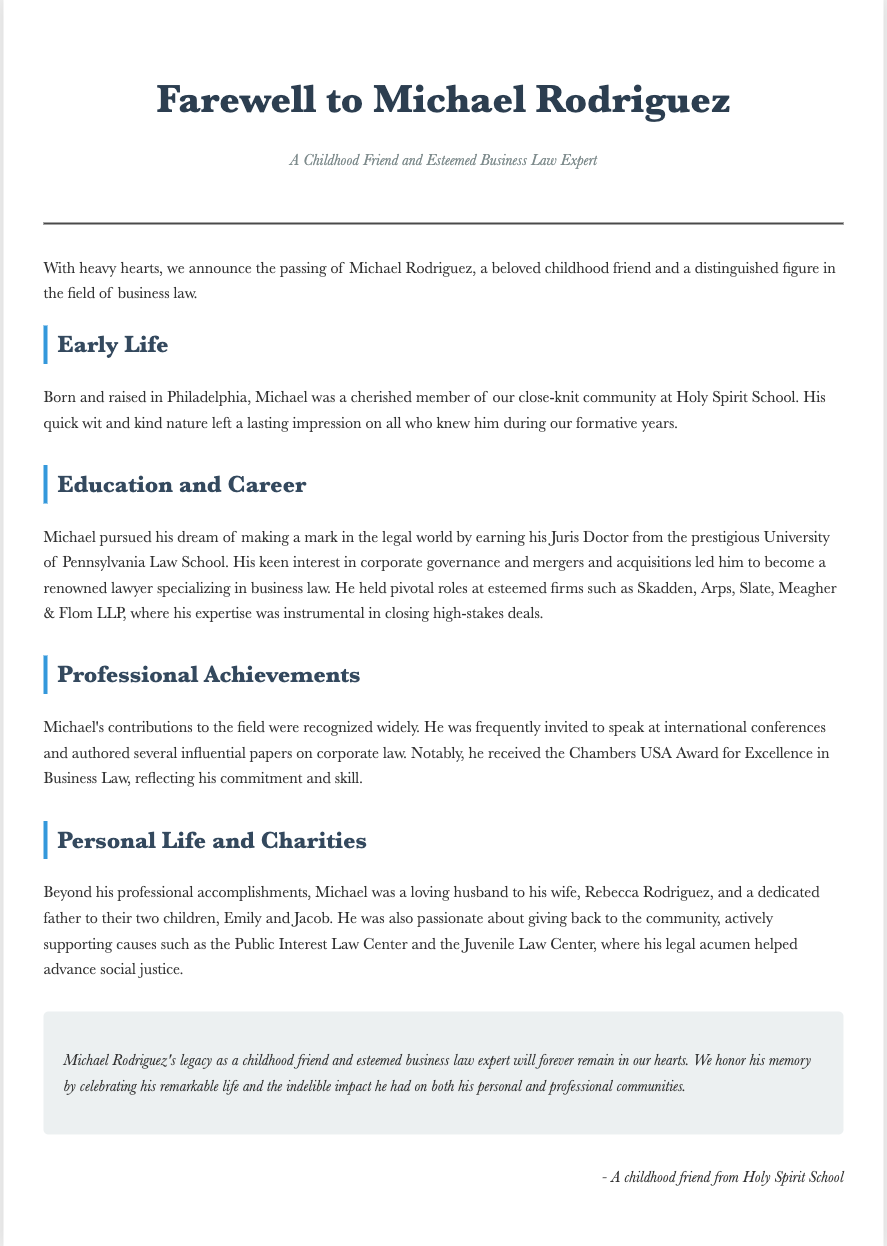What was Michael's profession? The document states that Michael was a distinguished figure in the field of business law.
Answer: business law Where did Michael obtain his Juris Doctor? According to the document, Michael earned his Juris Doctor from the prestigious University of Pennsylvania Law School.
Answer: University of Pennsylvania Law School What award did Michael receive for his work in business law? The document mentions that Michael received the Chambers USA Award for Excellence in Business Law.
Answer: Chambers USA Award for Excellence in Business Law How many children did Michael have? The document indicates that Michael was a dedicated father to two children, Emily and Jacob.
Answer: two Which charitable organizations did Michael actively support? The obituary mentions that Michael supported the Public Interest Law Center and the Juvenile Law Center.
Answer: Public Interest Law Center and Juvenile Law Center What city was Michael born and raised in? The document states that Michael was born and raised in Philadelphia.
Answer: Philadelphia What was Michael's wife's name? The obituary lists Michael's wife as Rebecca Rodriguez.
Answer: Rebecca Rodriguez Why is Michael's legacy described as lasting? The document states that Michael's contributions to both his personal and professional communities have made an indelible impact.
Answer: indelible impact What type of events was Michael frequently invited to speak at? The document mentions that Michael was frequently invited to speak at international conferences.
Answer: international conferences 